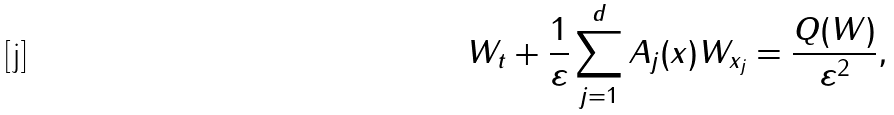<formula> <loc_0><loc_0><loc_500><loc_500>W _ { t } + \frac { 1 } { \varepsilon } \sum _ { j = 1 } ^ { d } A _ { j } ( x ) W _ { x _ { j } } = \frac { Q ( W ) } { \varepsilon ^ { 2 } } ,</formula> 